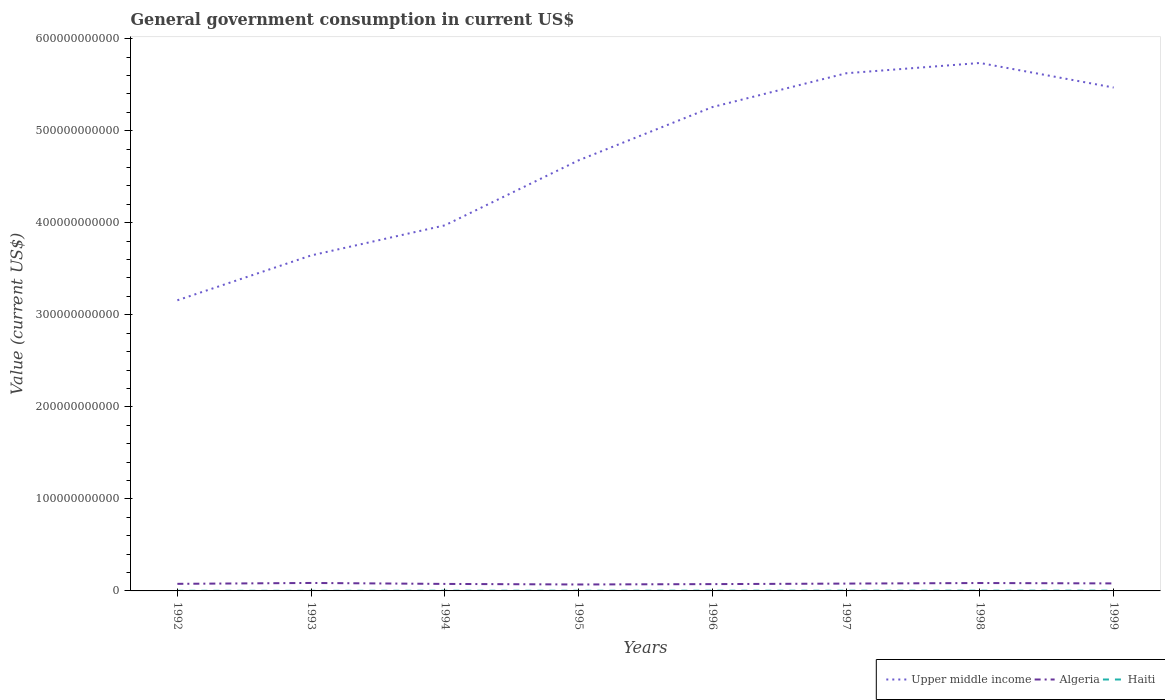Is the number of lines equal to the number of legend labels?
Provide a succinct answer. Yes. Across all years, what is the maximum government conusmption in Haiti?
Provide a short and direct response. 1.17e+08. What is the total government conusmption in Upper middle income in the graph?
Keep it short and to the point. -3.67e+1. What is the difference between the highest and the second highest government conusmption in Haiti?
Make the answer very short. 1.85e+08. What is the difference between the highest and the lowest government conusmption in Haiti?
Make the answer very short. 5. Is the government conusmption in Upper middle income strictly greater than the government conusmption in Algeria over the years?
Offer a terse response. No. How many lines are there?
Your answer should be very brief. 3. How many years are there in the graph?
Ensure brevity in your answer.  8. What is the difference between two consecutive major ticks on the Y-axis?
Your answer should be very brief. 1.00e+11. Does the graph contain grids?
Provide a short and direct response. No. How many legend labels are there?
Keep it short and to the point. 3. How are the legend labels stacked?
Keep it short and to the point. Horizontal. What is the title of the graph?
Your response must be concise. General government consumption in current US$. What is the label or title of the X-axis?
Give a very brief answer. Years. What is the label or title of the Y-axis?
Give a very brief answer. Value (current US$). What is the Value (current US$) of Upper middle income in 1992?
Your response must be concise. 3.16e+11. What is the Value (current US$) in Algeria in 1992?
Keep it short and to the point. 7.69e+09. What is the Value (current US$) in Haiti in 1992?
Give a very brief answer. 1.60e+08. What is the Value (current US$) in Upper middle income in 1993?
Your response must be concise. 3.64e+11. What is the Value (current US$) in Algeria in 1993?
Offer a very short reply. 8.65e+09. What is the Value (current US$) of Haiti in 1993?
Offer a terse response. 1.17e+08. What is the Value (current US$) in Upper middle income in 1994?
Your answer should be very brief. 3.97e+11. What is the Value (current US$) of Algeria in 1994?
Ensure brevity in your answer.  7.60e+09. What is the Value (current US$) in Haiti in 1994?
Provide a short and direct response. 2.33e+08. What is the Value (current US$) in Upper middle income in 1995?
Provide a short and direct response. 4.68e+11. What is the Value (current US$) of Algeria in 1995?
Your answer should be very brief. 7.00e+09. What is the Value (current US$) in Haiti in 1995?
Ensure brevity in your answer.  2.06e+08. What is the Value (current US$) of Upper middle income in 1996?
Make the answer very short. 5.26e+11. What is the Value (current US$) of Algeria in 1996?
Your answer should be compact. 7.40e+09. What is the Value (current US$) of Haiti in 1996?
Provide a short and direct response. 2.60e+08. What is the Value (current US$) of Upper middle income in 1997?
Give a very brief answer. 5.62e+11. What is the Value (current US$) in Algeria in 1997?
Keep it short and to the point. 7.97e+09. What is the Value (current US$) in Haiti in 1997?
Provide a succinct answer. 2.63e+08. What is the Value (current US$) in Upper middle income in 1998?
Keep it short and to the point. 5.74e+11. What is the Value (current US$) of Algeria in 1998?
Your answer should be compact. 8.57e+09. What is the Value (current US$) of Haiti in 1998?
Offer a terse response. 2.76e+08. What is the Value (current US$) of Upper middle income in 1999?
Your response must be concise. 5.47e+11. What is the Value (current US$) of Algeria in 1999?
Offer a terse response. 8.17e+09. What is the Value (current US$) in Haiti in 1999?
Offer a very short reply. 3.02e+08. Across all years, what is the maximum Value (current US$) of Upper middle income?
Your answer should be compact. 5.74e+11. Across all years, what is the maximum Value (current US$) in Algeria?
Offer a terse response. 8.65e+09. Across all years, what is the maximum Value (current US$) in Haiti?
Your answer should be compact. 3.02e+08. Across all years, what is the minimum Value (current US$) of Upper middle income?
Make the answer very short. 3.16e+11. Across all years, what is the minimum Value (current US$) of Algeria?
Your answer should be very brief. 7.00e+09. Across all years, what is the minimum Value (current US$) of Haiti?
Ensure brevity in your answer.  1.17e+08. What is the total Value (current US$) of Upper middle income in the graph?
Keep it short and to the point. 3.75e+12. What is the total Value (current US$) of Algeria in the graph?
Keep it short and to the point. 6.31e+1. What is the total Value (current US$) in Haiti in the graph?
Provide a short and direct response. 1.82e+09. What is the difference between the Value (current US$) in Upper middle income in 1992 and that in 1993?
Ensure brevity in your answer.  -4.87e+1. What is the difference between the Value (current US$) of Algeria in 1992 and that in 1993?
Your answer should be compact. -9.64e+08. What is the difference between the Value (current US$) in Haiti in 1992 and that in 1993?
Your response must be concise. 4.30e+07. What is the difference between the Value (current US$) of Upper middle income in 1992 and that in 1994?
Provide a short and direct response. -8.14e+1. What is the difference between the Value (current US$) in Algeria in 1992 and that in 1994?
Offer a very short reply. 8.48e+07. What is the difference between the Value (current US$) of Haiti in 1992 and that in 1994?
Keep it short and to the point. -7.34e+07. What is the difference between the Value (current US$) of Upper middle income in 1992 and that in 1995?
Offer a very short reply. -1.52e+11. What is the difference between the Value (current US$) in Algeria in 1992 and that in 1995?
Provide a succinct answer. 6.88e+08. What is the difference between the Value (current US$) of Haiti in 1992 and that in 1995?
Ensure brevity in your answer.  -4.59e+07. What is the difference between the Value (current US$) in Upper middle income in 1992 and that in 1996?
Your answer should be very brief. -2.10e+11. What is the difference between the Value (current US$) of Algeria in 1992 and that in 1996?
Offer a very short reply. 2.84e+08. What is the difference between the Value (current US$) of Haiti in 1992 and that in 1996?
Your answer should be compact. -1.00e+08. What is the difference between the Value (current US$) in Upper middle income in 1992 and that in 1997?
Provide a succinct answer. -2.47e+11. What is the difference between the Value (current US$) of Algeria in 1992 and that in 1997?
Ensure brevity in your answer.  -2.79e+08. What is the difference between the Value (current US$) of Haiti in 1992 and that in 1997?
Provide a short and direct response. -1.03e+08. What is the difference between the Value (current US$) of Upper middle income in 1992 and that in 1998?
Offer a very short reply. -2.58e+11. What is the difference between the Value (current US$) of Algeria in 1992 and that in 1998?
Your answer should be very brief. -8.84e+08. What is the difference between the Value (current US$) in Haiti in 1992 and that in 1998?
Make the answer very short. -1.16e+08. What is the difference between the Value (current US$) of Upper middle income in 1992 and that in 1999?
Make the answer very short. -2.31e+11. What is the difference between the Value (current US$) of Algeria in 1992 and that in 1999?
Your response must be concise. -4.76e+08. What is the difference between the Value (current US$) in Haiti in 1992 and that in 1999?
Give a very brief answer. -1.42e+08. What is the difference between the Value (current US$) in Upper middle income in 1993 and that in 1994?
Provide a short and direct response. -3.27e+1. What is the difference between the Value (current US$) in Algeria in 1993 and that in 1994?
Make the answer very short. 1.05e+09. What is the difference between the Value (current US$) of Haiti in 1993 and that in 1994?
Your answer should be compact. -1.16e+08. What is the difference between the Value (current US$) in Upper middle income in 1993 and that in 1995?
Give a very brief answer. -1.03e+11. What is the difference between the Value (current US$) in Algeria in 1993 and that in 1995?
Offer a very short reply. 1.65e+09. What is the difference between the Value (current US$) of Haiti in 1993 and that in 1995?
Ensure brevity in your answer.  -8.89e+07. What is the difference between the Value (current US$) in Upper middle income in 1993 and that in 1996?
Your answer should be compact. -1.61e+11. What is the difference between the Value (current US$) of Algeria in 1993 and that in 1996?
Provide a short and direct response. 1.25e+09. What is the difference between the Value (current US$) in Haiti in 1993 and that in 1996?
Your response must be concise. -1.43e+08. What is the difference between the Value (current US$) in Upper middle income in 1993 and that in 1997?
Your answer should be very brief. -1.98e+11. What is the difference between the Value (current US$) of Algeria in 1993 and that in 1997?
Make the answer very short. 6.85e+08. What is the difference between the Value (current US$) of Haiti in 1993 and that in 1997?
Your answer should be very brief. -1.46e+08. What is the difference between the Value (current US$) in Upper middle income in 1993 and that in 1998?
Provide a short and direct response. -2.09e+11. What is the difference between the Value (current US$) of Algeria in 1993 and that in 1998?
Keep it short and to the point. 7.93e+07. What is the difference between the Value (current US$) of Haiti in 1993 and that in 1998?
Provide a short and direct response. -1.59e+08. What is the difference between the Value (current US$) of Upper middle income in 1993 and that in 1999?
Give a very brief answer. -1.82e+11. What is the difference between the Value (current US$) of Algeria in 1993 and that in 1999?
Your response must be concise. 4.87e+08. What is the difference between the Value (current US$) of Haiti in 1993 and that in 1999?
Keep it short and to the point. -1.85e+08. What is the difference between the Value (current US$) of Upper middle income in 1994 and that in 1995?
Offer a terse response. -7.06e+1. What is the difference between the Value (current US$) of Algeria in 1994 and that in 1995?
Keep it short and to the point. 6.03e+08. What is the difference between the Value (current US$) in Haiti in 1994 and that in 1995?
Your answer should be very brief. 2.74e+07. What is the difference between the Value (current US$) in Upper middle income in 1994 and that in 1996?
Keep it short and to the point. -1.28e+11. What is the difference between the Value (current US$) in Algeria in 1994 and that in 1996?
Provide a succinct answer. 2.00e+08. What is the difference between the Value (current US$) of Haiti in 1994 and that in 1996?
Keep it short and to the point. -2.69e+07. What is the difference between the Value (current US$) in Upper middle income in 1994 and that in 1997?
Keep it short and to the point. -1.65e+11. What is the difference between the Value (current US$) in Algeria in 1994 and that in 1997?
Provide a short and direct response. -3.64e+08. What is the difference between the Value (current US$) in Haiti in 1994 and that in 1997?
Make the answer very short. -2.96e+07. What is the difference between the Value (current US$) of Upper middle income in 1994 and that in 1998?
Make the answer very short. -1.76e+11. What is the difference between the Value (current US$) in Algeria in 1994 and that in 1998?
Give a very brief answer. -9.69e+08. What is the difference between the Value (current US$) in Haiti in 1994 and that in 1998?
Your answer should be very brief. -4.24e+07. What is the difference between the Value (current US$) in Upper middle income in 1994 and that in 1999?
Ensure brevity in your answer.  -1.50e+11. What is the difference between the Value (current US$) of Algeria in 1994 and that in 1999?
Offer a very short reply. -5.61e+08. What is the difference between the Value (current US$) of Haiti in 1994 and that in 1999?
Your answer should be compact. -6.90e+07. What is the difference between the Value (current US$) in Upper middle income in 1995 and that in 1996?
Offer a very short reply. -5.78e+1. What is the difference between the Value (current US$) in Algeria in 1995 and that in 1996?
Offer a terse response. -4.03e+08. What is the difference between the Value (current US$) of Haiti in 1995 and that in 1996?
Your answer should be very brief. -5.43e+07. What is the difference between the Value (current US$) in Upper middle income in 1995 and that in 1997?
Make the answer very short. -9.46e+1. What is the difference between the Value (current US$) in Algeria in 1995 and that in 1997?
Give a very brief answer. -9.67e+08. What is the difference between the Value (current US$) in Haiti in 1995 and that in 1997?
Your response must be concise. -5.70e+07. What is the difference between the Value (current US$) of Upper middle income in 1995 and that in 1998?
Provide a succinct answer. -1.06e+11. What is the difference between the Value (current US$) in Algeria in 1995 and that in 1998?
Offer a very short reply. -1.57e+09. What is the difference between the Value (current US$) of Haiti in 1995 and that in 1998?
Ensure brevity in your answer.  -6.98e+07. What is the difference between the Value (current US$) of Upper middle income in 1995 and that in 1999?
Provide a succinct answer. -7.91e+1. What is the difference between the Value (current US$) in Algeria in 1995 and that in 1999?
Provide a succinct answer. -1.16e+09. What is the difference between the Value (current US$) of Haiti in 1995 and that in 1999?
Your response must be concise. -9.64e+07. What is the difference between the Value (current US$) in Upper middle income in 1996 and that in 1997?
Make the answer very short. -3.67e+1. What is the difference between the Value (current US$) of Algeria in 1996 and that in 1997?
Offer a terse response. -5.63e+08. What is the difference between the Value (current US$) in Haiti in 1996 and that in 1997?
Your answer should be very brief. -2.66e+06. What is the difference between the Value (current US$) of Upper middle income in 1996 and that in 1998?
Your answer should be very brief. -4.79e+1. What is the difference between the Value (current US$) of Algeria in 1996 and that in 1998?
Offer a terse response. -1.17e+09. What is the difference between the Value (current US$) in Haiti in 1996 and that in 1998?
Offer a very short reply. -1.55e+07. What is the difference between the Value (current US$) of Upper middle income in 1996 and that in 1999?
Ensure brevity in your answer.  -2.12e+1. What is the difference between the Value (current US$) of Algeria in 1996 and that in 1999?
Offer a very short reply. -7.61e+08. What is the difference between the Value (current US$) of Haiti in 1996 and that in 1999?
Make the answer very short. -4.21e+07. What is the difference between the Value (current US$) of Upper middle income in 1997 and that in 1998?
Give a very brief answer. -1.12e+1. What is the difference between the Value (current US$) in Algeria in 1997 and that in 1998?
Offer a very short reply. -6.06e+08. What is the difference between the Value (current US$) in Haiti in 1997 and that in 1998?
Your response must be concise. -1.28e+07. What is the difference between the Value (current US$) of Upper middle income in 1997 and that in 1999?
Keep it short and to the point. 1.55e+1. What is the difference between the Value (current US$) of Algeria in 1997 and that in 1999?
Give a very brief answer. -1.98e+08. What is the difference between the Value (current US$) in Haiti in 1997 and that in 1999?
Ensure brevity in your answer.  -3.94e+07. What is the difference between the Value (current US$) in Upper middle income in 1998 and that in 1999?
Provide a succinct answer. 2.67e+1. What is the difference between the Value (current US$) of Algeria in 1998 and that in 1999?
Keep it short and to the point. 4.08e+08. What is the difference between the Value (current US$) of Haiti in 1998 and that in 1999?
Your answer should be very brief. -2.66e+07. What is the difference between the Value (current US$) in Upper middle income in 1992 and the Value (current US$) in Algeria in 1993?
Make the answer very short. 3.07e+11. What is the difference between the Value (current US$) in Upper middle income in 1992 and the Value (current US$) in Haiti in 1993?
Offer a very short reply. 3.16e+11. What is the difference between the Value (current US$) of Algeria in 1992 and the Value (current US$) of Haiti in 1993?
Give a very brief answer. 7.57e+09. What is the difference between the Value (current US$) in Upper middle income in 1992 and the Value (current US$) in Algeria in 1994?
Your response must be concise. 3.08e+11. What is the difference between the Value (current US$) in Upper middle income in 1992 and the Value (current US$) in Haiti in 1994?
Your response must be concise. 3.16e+11. What is the difference between the Value (current US$) of Algeria in 1992 and the Value (current US$) of Haiti in 1994?
Offer a terse response. 7.46e+09. What is the difference between the Value (current US$) of Upper middle income in 1992 and the Value (current US$) of Algeria in 1995?
Your answer should be very brief. 3.09e+11. What is the difference between the Value (current US$) in Upper middle income in 1992 and the Value (current US$) in Haiti in 1995?
Provide a short and direct response. 3.16e+11. What is the difference between the Value (current US$) of Algeria in 1992 and the Value (current US$) of Haiti in 1995?
Offer a terse response. 7.48e+09. What is the difference between the Value (current US$) of Upper middle income in 1992 and the Value (current US$) of Algeria in 1996?
Give a very brief answer. 3.08e+11. What is the difference between the Value (current US$) of Upper middle income in 1992 and the Value (current US$) of Haiti in 1996?
Offer a terse response. 3.15e+11. What is the difference between the Value (current US$) of Algeria in 1992 and the Value (current US$) of Haiti in 1996?
Offer a terse response. 7.43e+09. What is the difference between the Value (current US$) in Upper middle income in 1992 and the Value (current US$) in Algeria in 1997?
Your response must be concise. 3.08e+11. What is the difference between the Value (current US$) in Upper middle income in 1992 and the Value (current US$) in Haiti in 1997?
Your answer should be compact. 3.15e+11. What is the difference between the Value (current US$) of Algeria in 1992 and the Value (current US$) of Haiti in 1997?
Provide a short and direct response. 7.43e+09. What is the difference between the Value (current US$) of Upper middle income in 1992 and the Value (current US$) of Algeria in 1998?
Provide a succinct answer. 3.07e+11. What is the difference between the Value (current US$) in Upper middle income in 1992 and the Value (current US$) in Haiti in 1998?
Give a very brief answer. 3.15e+11. What is the difference between the Value (current US$) of Algeria in 1992 and the Value (current US$) of Haiti in 1998?
Keep it short and to the point. 7.41e+09. What is the difference between the Value (current US$) of Upper middle income in 1992 and the Value (current US$) of Algeria in 1999?
Offer a very short reply. 3.08e+11. What is the difference between the Value (current US$) of Upper middle income in 1992 and the Value (current US$) of Haiti in 1999?
Give a very brief answer. 3.15e+11. What is the difference between the Value (current US$) of Algeria in 1992 and the Value (current US$) of Haiti in 1999?
Your answer should be very brief. 7.39e+09. What is the difference between the Value (current US$) of Upper middle income in 1993 and the Value (current US$) of Algeria in 1994?
Offer a terse response. 3.57e+11. What is the difference between the Value (current US$) in Upper middle income in 1993 and the Value (current US$) in Haiti in 1994?
Make the answer very short. 3.64e+11. What is the difference between the Value (current US$) of Algeria in 1993 and the Value (current US$) of Haiti in 1994?
Give a very brief answer. 8.42e+09. What is the difference between the Value (current US$) in Upper middle income in 1993 and the Value (current US$) in Algeria in 1995?
Keep it short and to the point. 3.57e+11. What is the difference between the Value (current US$) in Upper middle income in 1993 and the Value (current US$) in Haiti in 1995?
Give a very brief answer. 3.64e+11. What is the difference between the Value (current US$) of Algeria in 1993 and the Value (current US$) of Haiti in 1995?
Your answer should be very brief. 8.45e+09. What is the difference between the Value (current US$) of Upper middle income in 1993 and the Value (current US$) of Algeria in 1996?
Your answer should be compact. 3.57e+11. What is the difference between the Value (current US$) in Upper middle income in 1993 and the Value (current US$) in Haiti in 1996?
Your response must be concise. 3.64e+11. What is the difference between the Value (current US$) of Algeria in 1993 and the Value (current US$) of Haiti in 1996?
Offer a terse response. 8.39e+09. What is the difference between the Value (current US$) in Upper middle income in 1993 and the Value (current US$) in Algeria in 1997?
Your answer should be compact. 3.57e+11. What is the difference between the Value (current US$) in Upper middle income in 1993 and the Value (current US$) in Haiti in 1997?
Provide a short and direct response. 3.64e+11. What is the difference between the Value (current US$) in Algeria in 1993 and the Value (current US$) in Haiti in 1997?
Ensure brevity in your answer.  8.39e+09. What is the difference between the Value (current US$) in Upper middle income in 1993 and the Value (current US$) in Algeria in 1998?
Make the answer very short. 3.56e+11. What is the difference between the Value (current US$) in Upper middle income in 1993 and the Value (current US$) in Haiti in 1998?
Give a very brief answer. 3.64e+11. What is the difference between the Value (current US$) of Algeria in 1993 and the Value (current US$) of Haiti in 1998?
Your answer should be very brief. 8.38e+09. What is the difference between the Value (current US$) of Upper middle income in 1993 and the Value (current US$) of Algeria in 1999?
Provide a succinct answer. 3.56e+11. What is the difference between the Value (current US$) in Upper middle income in 1993 and the Value (current US$) in Haiti in 1999?
Provide a succinct answer. 3.64e+11. What is the difference between the Value (current US$) of Algeria in 1993 and the Value (current US$) of Haiti in 1999?
Your response must be concise. 8.35e+09. What is the difference between the Value (current US$) of Upper middle income in 1994 and the Value (current US$) of Algeria in 1995?
Offer a terse response. 3.90e+11. What is the difference between the Value (current US$) of Upper middle income in 1994 and the Value (current US$) of Haiti in 1995?
Keep it short and to the point. 3.97e+11. What is the difference between the Value (current US$) in Algeria in 1994 and the Value (current US$) in Haiti in 1995?
Make the answer very short. 7.40e+09. What is the difference between the Value (current US$) in Upper middle income in 1994 and the Value (current US$) in Algeria in 1996?
Make the answer very short. 3.90e+11. What is the difference between the Value (current US$) of Upper middle income in 1994 and the Value (current US$) of Haiti in 1996?
Your answer should be very brief. 3.97e+11. What is the difference between the Value (current US$) of Algeria in 1994 and the Value (current US$) of Haiti in 1996?
Offer a very short reply. 7.34e+09. What is the difference between the Value (current US$) of Upper middle income in 1994 and the Value (current US$) of Algeria in 1997?
Your response must be concise. 3.89e+11. What is the difference between the Value (current US$) in Upper middle income in 1994 and the Value (current US$) in Haiti in 1997?
Provide a succinct answer. 3.97e+11. What is the difference between the Value (current US$) in Algeria in 1994 and the Value (current US$) in Haiti in 1997?
Make the answer very short. 7.34e+09. What is the difference between the Value (current US$) of Upper middle income in 1994 and the Value (current US$) of Algeria in 1998?
Offer a terse response. 3.89e+11. What is the difference between the Value (current US$) of Upper middle income in 1994 and the Value (current US$) of Haiti in 1998?
Your answer should be very brief. 3.97e+11. What is the difference between the Value (current US$) in Algeria in 1994 and the Value (current US$) in Haiti in 1998?
Give a very brief answer. 7.33e+09. What is the difference between the Value (current US$) of Upper middle income in 1994 and the Value (current US$) of Algeria in 1999?
Your answer should be very brief. 3.89e+11. What is the difference between the Value (current US$) of Upper middle income in 1994 and the Value (current US$) of Haiti in 1999?
Keep it short and to the point. 3.97e+11. What is the difference between the Value (current US$) of Algeria in 1994 and the Value (current US$) of Haiti in 1999?
Make the answer very short. 7.30e+09. What is the difference between the Value (current US$) of Upper middle income in 1995 and the Value (current US$) of Algeria in 1996?
Your response must be concise. 4.60e+11. What is the difference between the Value (current US$) in Upper middle income in 1995 and the Value (current US$) in Haiti in 1996?
Make the answer very short. 4.68e+11. What is the difference between the Value (current US$) in Algeria in 1995 and the Value (current US$) in Haiti in 1996?
Offer a very short reply. 6.74e+09. What is the difference between the Value (current US$) of Upper middle income in 1995 and the Value (current US$) of Algeria in 1997?
Offer a terse response. 4.60e+11. What is the difference between the Value (current US$) in Upper middle income in 1995 and the Value (current US$) in Haiti in 1997?
Ensure brevity in your answer.  4.68e+11. What is the difference between the Value (current US$) in Algeria in 1995 and the Value (current US$) in Haiti in 1997?
Offer a terse response. 6.74e+09. What is the difference between the Value (current US$) in Upper middle income in 1995 and the Value (current US$) in Algeria in 1998?
Your response must be concise. 4.59e+11. What is the difference between the Value (current US$) of Upper middle income in 1995 and the Value (current US$) of Haiti in 1998?
Your response must be concise. 4.68e+11. What is the difference between the Value (current US$) of Algeria in 1995 and the Value (current US$) of Haiti in 1998?
Ensure brevity in your answer.  6.73e+09. What is the difference between the Value (current US$) of Upper middle income in 1995 and the Value (current US$) of Algeria in 1999?
Your answer should be very brief. 4.60e+11. What is the difference between the Value (current US$) in Upper middle income in 1995 and the Value (current US$) in Haiti in 1999?
Ensure brevity in your answer.  4.68e+11. What is the difference between the Value (current US$) of Algeria in 1995 and the Value (current US$) of Haiti in 1999?
Offer a very short reply. 6.70e+09. What is the difference between the Value (current US$) in Upper middle income in 1996 and the Value (current US$) in Algeria in 1997?
Your answer should be compact. 5.18e+11. What is the difference between the Value (current US$) of Upper middle income in 1996 and the Value (current US$) of Haiti in 1997?
Offer a terse response. 5.25e+11. What is the difference between the Value (current US$) of Algeria in 1996 and the Value (current US$) of Haiti in 1997?
Your response must be concise. 7.14e+09. What is the difference between the Value (current US$) in Upper middle income in 1996 and the Value (current US$) in Algeria in 1998?
Offer a terse response. 5.17e+11. What is the difference between the Value (current US$) of Upper middle income in 1996 and the Value (current US$) of Haiti in 1998?
Offer a very short reply. 5.25e+11. What is the difference between the Value (current US$) of Algeria in 1996 and the Value (current US$) of Haiti in 1998?
Your answer should be very brief. 7.13e+09. What is the difference between the Value (current US$) in Upper middle income in 1996 and the Value (current US$) in Algeria in 1999?
Provide a succinct answer. 5.17e+11. What is the difference between the Value (current US$) of Upper middle income in 1996 and the Value (current US$) of Haiti in 1999?
Provide a succinct answer. 5.25e+11. What is the difference between the Value (current US$) of Algeria in 1996 and the Value (current US$) of Haiti in 1999?
Ensure brevity in your answer.  7.10e+09. What is the difference between the Value (current US$) of Upper middle income in 1997 and the Value (current US$) of Algeria in 1998?
Make the answer very short. 5.54e+11. What is the difference between the Value (current US$) of Upper middle income in 1997 and the Value (current US$) of Haiti in 1998?
Offer a terse response. 5.62e+11. What is the difference between the Value (current US$) in Algeria in 1997 and the Value (current US$) in Haiti in 1998?
Keep it short and to the point. 7.69e+09. What is the difference between the Value (current US$) of Upper middle income in 1997 and the Value (current US$) of Algeria in 1999?
Your response must be concise. 5.54e+11. What is the difference between the Value (current US$) of Upper middle income in 1997 and the Value (current US$) of Haiti in 1999?
Provide a short and direct response. 5.62e+11. What is the difference between the Value (current US$) of Algeria in 1997 and the Value (current US$) of Haiti in 1999?
Your answer should be very brief. 7.67e+09. What is the difference between the Value (current US$) in Upper middle income in 1998 and the Value (current US$) in Algeria in 1999?
Provide a short and direct response. 5.65e+11. What is the difference between the Value (current US$) of Upper middle income in 1998 and the Value (current US$) of Haiti in 1999?
Give a very brief answer. 5.73e+11. What is the difference between the Value (current US$) in Algeria in 1998 and the Value (current US$) in Haiti in 1999?
Your response must be concise. 8.27e+09. What is the average Value (current US$) in Upper middle income per year?
Your response must be concise. 4.69e+11. What is the average Value (current US$) in Algeria per year?
Provide a short and direct response. 7.88e+09. What is the average Value (current US$) of Haiti per year?
Your answer should be compact. 2.27e+08. In the year 1992, what is the difference between the Value (current US$) in Upper middle income and Value (current US$) in Algeria?
Your response must be concise. 3.08e+11. In the year 1992, what is the difference between the Value (current US$) of Upper middle income and Value (current US$) of Haiti?
Offer a very short reply. 3.16e+11. In the year 1992, what is the difference between the Value (current US$) in Algeria and Value (current US$) in Haiti?
Provide a short and direct response. 7.53e+09. In the year 1993, what is the difference between the Value (current US$) of Upper middle income and Value (current US$) of Algeria?
Your response must be concise. 3.56e+11. In the year 1993, what is the difference between the Value (current US$) in Upper middle income and Value (current US$) in Haiti?
Give a very brief answer. 3.64e+11. In the year 1993, what is the difference between the Value (current US$) in Algeria and Value (current US$) in Haiti?
Offer a terse response. 8.54e+09. In the year 1994, what is the difference between the Value (current US$) of Upper middle income and Value (current US$) of Algeria?
Ensure brevity in your answer.  3.90e+11. In the year 1994, what is the difference between the Value (current US$) in Upper middle income and Value (current US$) in Haiti?
Your response must be concise. 3.97e+11. In the year 1994, what is the difference between the Value (current US$) in Algeria and Value (current US$) in Haiti?
Provide a succinct answer. 7.37e+09. In the year 1995, what is the difference between the Value (current US$) of Upper middle income and Value (current US$) of Algeria?
Offer a very short reply. 4.61e+11. In the year 1995, what is the difference between the Value (current US$) in Upper middle income and Value (current US$) in Haiti?
Give a very brief answer. 4.68e+11. In the year 1995, what is the difference between the Value (current US$) in Algeria and Value (current US$) in Haiti?
Your answer should be compact. 6.80e+09. In the year 1996, what is the difference between the Value (current US$) of Upper middle income and Value (current US$) of Algeria?
Keep it short and to the point. 5.18e+11. In the year 1996, what is the difference between the Value (current US$) in Upper middle income and Value (current US$) in Haiti?
Your answer should be very brief. 5.25e+11. In the year 1996, what is the difference between the Value (current US$) of Algeria and Value (current US$) of Haiti?
Provide a short and direct response. 7.14e+09. In the year 1997, what is the difference between the Value (current US$) of Upper middle income and Value (current US$) of Algeria?
Give a very brief answer. 5.54e+11. In the year 1997, what is the difference between the Value (current US$) of Upper middle income and Value (current US$) of Haiti?
Make the answer very short. 5.62e+11. In the year 1997, what is the difference between the Value (current US$) in Algeria and Value (current US$) in Haiti?
Your answer should be very brief. 7.71e+09. In the year 1998, what is the difference between the Value (current US$) of Upper middle income and Value (current US$) of Algeria?
Your answer should be compact. 5.65e+11. In the year 1998, what is the difference between the Value (current US$) in Upper middle income and Value (current US$) in Haiti?
Provide a succinct answer. 5.73e+11. In the year 1998, what is the difference between the Value (current US$) of Algeria and Value (current US$) of Haiti?
Provide a succinct answer. 8.30e+09. In the year 1999, what is the difference between the Value (current US$) in Upper middle income and Value (current US$) in Algeria?
Ensure brevity in your answer.  5.39e+11. In the year 1999, what is the difference between the Value (current US$) of Upper middle income and Value (current US$) of Haiti?
Offer a terse response. 5.47e+11. In the year 1999, what is the difference between the Value (current US$) of Algeria and Value (current US$) of Haiti?
Provide a succinct answer. 7.86e+09. What is the ratio of the Value (current US$) of Upper middle income in 1992 to that in 1993?
Your answer should be compact. 0.87. What is the ratio of the Value (current US$) of Algeria in 1992 to that in 1993?
Offer a very short reply. 0.89. What is the ratio of the Value (current US$) in Haiti in 1992 to that in 1993?
Your response must be concise. 1.37. What is the ratio of the Value (current US$) in Upper middle income in 1992 to that in 1994?
Your response must be concise. 0.8. What is the ratio of the Value (current US$) in Algeria in 1992 to that in 1994?
Make the answer very short. 1.01. What is the ratio of the Value (current US$) of Haiti in 1992 to that in 1994?
Offer a terse response. 0.69. What is the ratio of the Value (current US$) in Upper middle income in 1992 to that in 1995?
Offer a very short reply. 0.67. What is the ratio of the Value (current US$) in Algeria in 1992 to that in 1995?
Your answer should be compact. 1.1. What is the ratio of the Value (current US$) in Haiti in 1992 to that in 1995?
Ensure brevity in your answer.  0.78. What is the ratio of the Value (current US$) of Upper middle income in 1992 to that in 1996?
Your answer should be compact. 0.6. What is the ratio of the Value (current US$) in Algeria in 1992 to that in 1996?
Ensure brevity in your answer.  1.04. What is the ratio of the Value (current US$) in Haiti in 1992 to that in 1996?
Provide a short and direct response. 0.61. What is the ratio of the Value (current US$) of Upper middle income in 1992 to that in 1997?
Give a very brief answer. 0.56. What is the ratio of the Value (current US$) of Haiti in 1992 to that in 1997?
Provide a short and direct response. 0.61. What is the ratio of the Value (current US$) of Upper middle income in 1992 to that in 1998?
Your response must be concise. 0.55. What is the ratio of the Value (current US$) of Algeria in 1992 to that in 1998?
Make the answer very short. 0.9. What is the ratio of the Value (current US$) in Haiti in 1992 to that in 1998?
Your answer should be very brief. 0.58. What is the ratio of the Value (current US$) in Upper middle income in 1992 to that in 1999?
Make the answer very short. 0.58. What is the ratio of the Value (current US$) in Algeria in 1992 to that in 1999?
Keep it short and to the point. 0.94. What is the ratio of the Value (current US$) of Haiti in 1992 to that in 1999?
Your response must be concise. 0.53. What is the ratio of the Value (current US$) in Upper middle income in 1993 to that in 1994?
Offer a very short reply. 0.92. What is the ratio of the Value (current US$) in Algeria in 1993 to that in 1994?
Give a very brief answer. 1.14. What is the ratio of the Value (current US$) in Haiti in 1993 to that in 1994?
Keep it short and to the point. 0.5. What is the ratio of the Value (current US$) of Upper middle income in 1993 to that in 1995?
Give a very brief answer. 0.78. What is the ratio of the Value (current US$) of Algeria in 1993 to that in 1995?
Offer a terse response. 1.24. What is the ratio of the Value (current US$) in Haiti in 1993 to that in 1995?
Your answer should be compact. 0.57. What is the ratio of the Value (current US$) of Upper middle income in 1993 to that in 1996?
Ensure brevity in your answer.  0.69. What is the ratio of the Value (current US$) in Algeria in 1993 to that in 1996?
Give a very brief answer. 1.17. What is the ratio of the Value (current US$) of Haiti in 1993 to that in 1996?
Give a very brief answer. 0.45. What is the ratio of the Value (current US$) of Upper middle income in 1993 to that in 1997?
Offer a terse response. 0.65. What is the ratio of the Value (current US$) of Algeria in 1993 to that in 1997?
Offer a terse response. 1.09. What is the ratio of the Value (current US$) of Haiti in 1993 to that in 1997?
Make the answer very short. 0.44. What is the ratio of the Value (current US$) in Upper middle income in 1993 to that in 1998?
Make the answer very short. 0.64. What is the ratio of the Value (current US$) in Algeria in 1993 to that in 1998?
Make the answer very short. 1.01. What is the ratio of the Value (current US$) of Haiti in 1993 to that in 1998?
Ensure brevity in your answer.  0.42. What is the ratio of the Value (current US$) in Upper middle income in 1993 to that in 1999?
Ensure brevity in your answer.  0.67. What is the ratio of the Value (current US$) of Algeria in 1993 to that in 1999?
Keep it short and to the point. 1.06. What is the ratio of the Value (current US$) in Haiti in 1993 to that in 1999?
Give a very brief answer. 0.39. What is the ratio of the Value (current US$) of Upper middle income in 1994 to that in 1995?
Keep it short and to the point. 0.85. What is the ratio of the Value (current US$) of Algeria in 1994 to that in 1995?
Provide a succinct answer. 1.09. What is the ratio of the Value (current US$) in Haiti in 1994 to that in 1995?
Your answer should be very brief. 1.13. What is the ratio of the Value (current US$) of Upper middle income in 1994 to that in 1996?
Keep it short and to the point. 0.76. What is the ratio of the Value (current US$) of Haiti in 1994 to that in 1996?
Provide a succinct answer. 0.9. What is the ratio of the Value (current US$) in Upper middle income in 1994 to that in 1997?
Keep it short and to the point. 0.71. What is the ratio of the Value (current US$) of Algeria in 1994 to that in 1997?
Provide a succinct answer. 0.95. What is the ratio of the Value (current US$) in Haiti in 1994 to that in 1997?
Keep it short and to the point. 0.89. What is the ratio of the Value (current US$) in Upper middle income in 1994 to that in 1998?
Keep it short and to the point. 0.69. What is the ratio of the Value (current US$) in Algeria in 1994 to that in 1998?
Keep it short and to the point. 0.89. What is the ratio of the Value (current US$) of Haiti in 1994 to that in 1998?
Keep it short and to the point. 0.85. What is the ratio of the Value (current US$) in Upper middle income in 1994 to that in 1999?
Offer a terse response. 0.73. What is the ratio of the Value (current US$) in Algeria in 1994 to that in 1999?
Your answer should be compact. 0.93. What is the ratio of the Value (current US$) of Haiti in 1994 to that in 1999?
Your answer should be compact. 0.77. What is the ratio of the Value (current US$) in Upper middle income in 1995 to that in 1996?
Keep it short and to the point. 0.89. What is the ratio of the Value (current US$) of Algeria in 1995 to that in 1996?
Your answer should be compact. 0.95. What is the ratio of the Value (current US$) in Haiti in 1995 to that in 1996?
Make the answer very short. 0.79. What is the ratio of the Value (current US$) of Upper middle income in 1995 to that in 1997?
Ensure brevity in your answer.  0.83. What is the ratio of the Value (current US$) in Algeria in 1995 to that in 1997?
Your answer should be very brief. 0.88. What is the ratio of the Value (current US$) of Haiti in 1995 to that in 1997?
Your answer should be compact. 0.78. What is the ratio of the Value (current US$) of Upper middle income in 1995 to that in 1998?
Offer a very short reply. 0.82. What is the ratio of the Value (current US$) of Algeria in 1995 to that in 1998?
Keep it short and to the point. 0.82. What is the ratio of the Value (current US$) of Haiti in 1995 to that in 1998?
Offer a very short reply. 0.75. What is the ratio of the Value (current US$) in Upper middle income in 1995 to that in 1999?
Provide a succinct answer. 0.86. What is the ratio of the Value (current US$) of Algeria in 1995 to that in 1999?
Give a very brief answer. 0.86. What is the ratio of the Value (current US$) of Haiti in 1995 to that in 1999?
Your response must be concise. 0.68. What is the ratio of the Value (current US$) in Upper middle income in 1996 to that in 1997?
Offer a very short reply. 0.93. What is the ratio of the Value (current US$) of Algeria in 1996 to that in 1997?
Ensure brevity in your answer.  0.93. What is the ratio of the Value (current US$) in Upper middle income in 1996 to that in 1998?
Offer a terse response. 0.92. What is the ratio of the Value (current US$) in Algeria in 1996 to that in 1998?
Offer a very short reply. 0.86. What is the ratio of the Value (current US$) in Haiti in 1996 to that in 1998?
Make the answer very short. 0.94. What is the ratio of the Value (current US$) of Upper middle income in 1996 to that in 1999?
Ensure brevity in your answer.  0.96. What is the ratio of the Value (current US$) in Algeria in 1996 to that in 1999?
Ensure brevity in your answer.  0.91. What is the ratio of the Value (current US$) in Haiti in 1996 to that in 1999?
Your answer should be very brief. 0.86. What is the ratio of the Value (current US$) in Upper middle income in 1997 to that in 1998?
Keep it short and to the point. 0.98. What is the ratio of the Value (current US$) of Algeria in 1997 to that in 1998?
Ensure brevity in your answer.  0.93. What is the ratio of the Value (current US$) of Haiti in 1997 to that in 1998?
Your answer should be compact. 0.95. What is the ratio of the Value (current US$) of Upper middle income in 1997 to that in 1999?
Your answer should be compact. 1.03. What is the ratio of the Value (current US$) of Algeria in 1997 to that in 1999?
Ensure brevity in your answer.  0.98. What is the ratio of the Value (current US$) of Haiti in 1997 to that in 1999?
Ensure brevity in your answer.  0.87. What is the ratio of the Value (current US$) in Upper middle income in 1998 to that in 1999?
Provide a short and direct response. 1.05. What is the ratio of the Value (current US$) of Haiti in 1998 to that in 1999?
Offer a very short reply. 0.91. What is the difference between the highest and the second highest Value (current US$) in Upper middle income?
Provide a short and direct response. 1.12e+1. What is the difference between the highest and the second highest Value (current US$) of Algeria?
Your answer should be very brief. 7.93e+07. What is the difference between the highest and the second highest Value (current US$) in Haiti?
Offer a terse response. 2.66e+07. What is the difference between the highest and the lowest Value (current US$) of Upper middle income?
Offer a terse response. 2.58e+11. What is the difference between the highest and the lowest Value (current US$) in Algeria?
Keep it short and to the point. 1.65e+09. What is the difference between the highest and the lowest Value (current US$) of Haiti?
Your answer should be compact. 1.85e+08. 